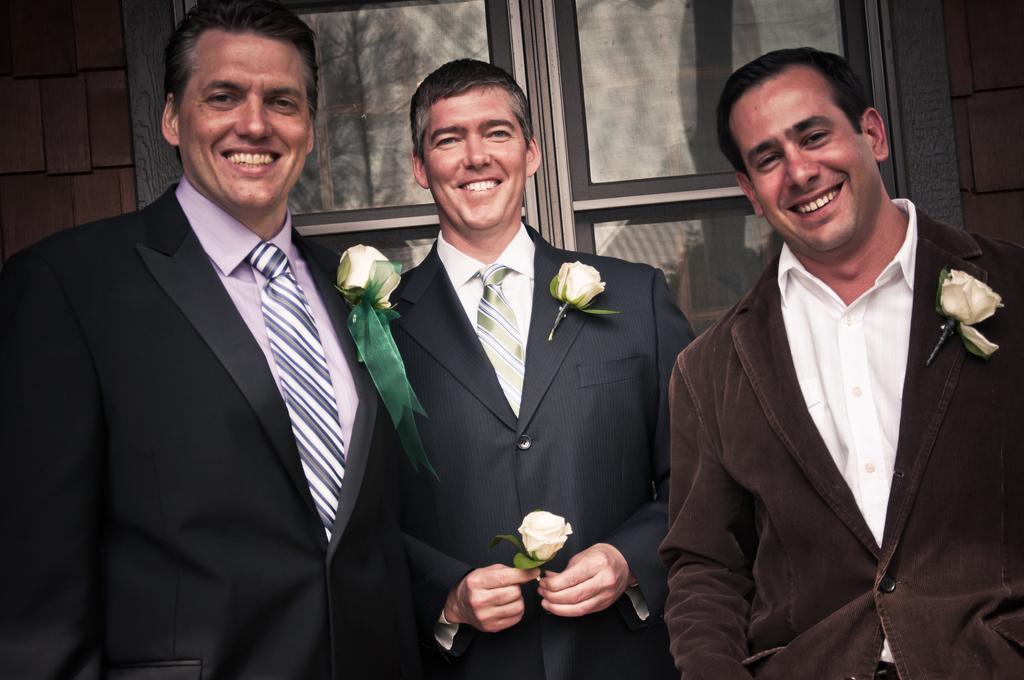Describe this image in one or two sentences. In this image we can see three persons in which one of them is holding a flower, there we can see three flowers attached to the person's dress, behind them, we can see a window, wall and some reflections of trees in the window. 